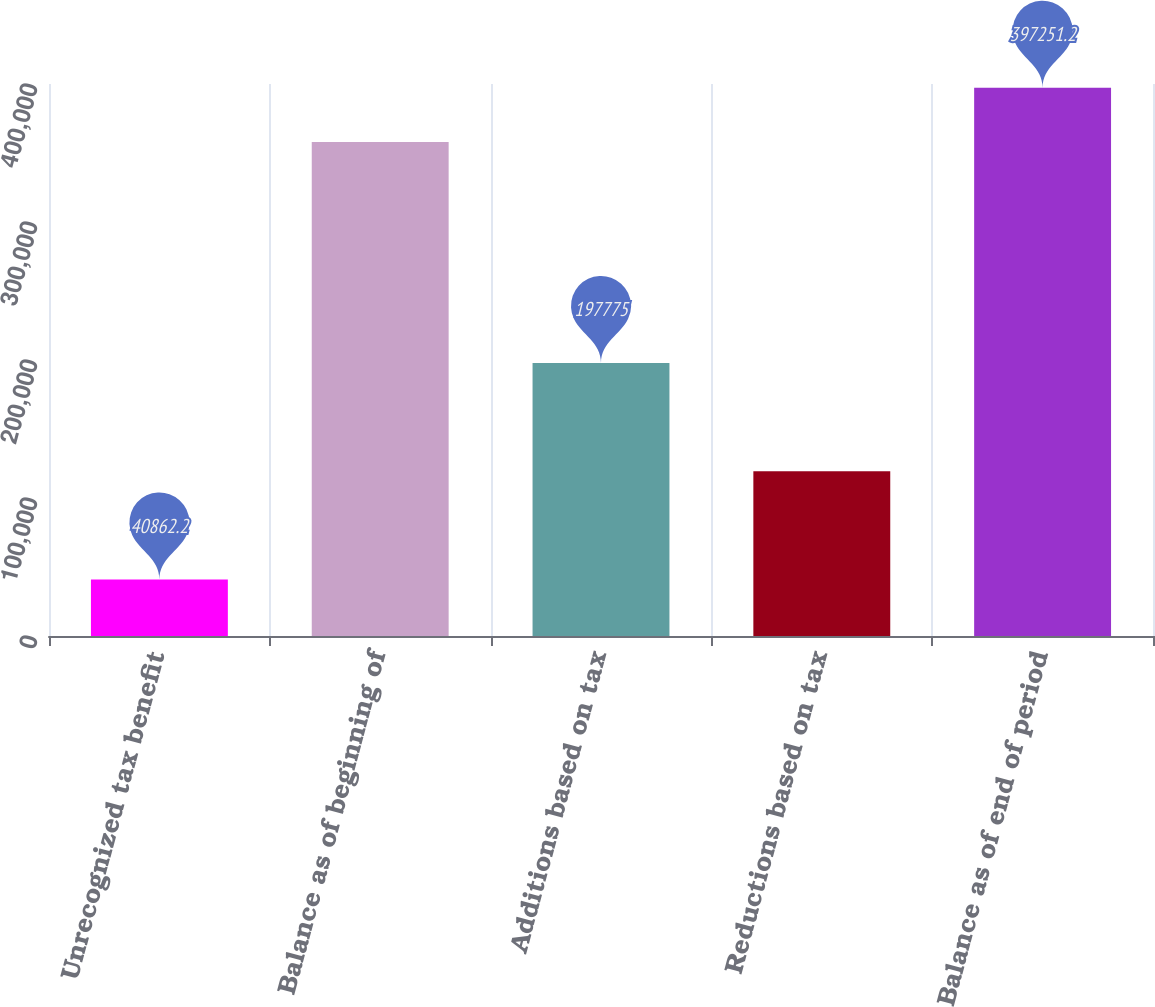Convert chart to OTSL. <chart><loc_0><loc_0><loc_500><loc_500><bar_chart><fcel>Unrecognized tax benefit<fcel>Balance as of beginning of<fcel>Additions based on tax<fcel>Reductions based on tax<fcel>Balance as of end of period<nl><fcel>40862.2<fcel>358023<fcel>197775<fcel>119319<fcel>397251<nl></chart> 